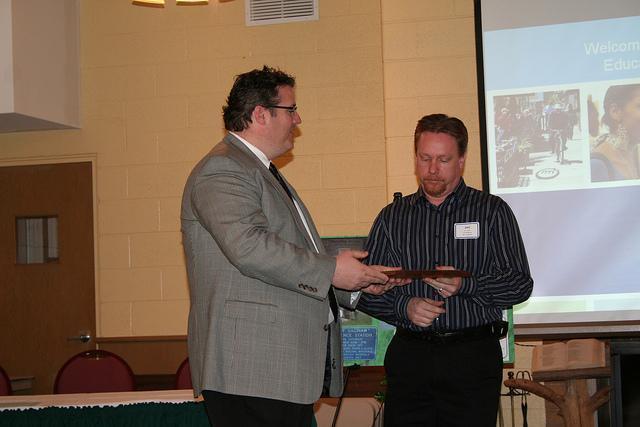How many people?
Give a very brief answer. 2. How many people can be seen?
Give a very brief answer. 2. How many books are there?
Give a very brief answer. 1. How many airplanes have a vehicle under their wing?
Give a very brief answer. 0. 